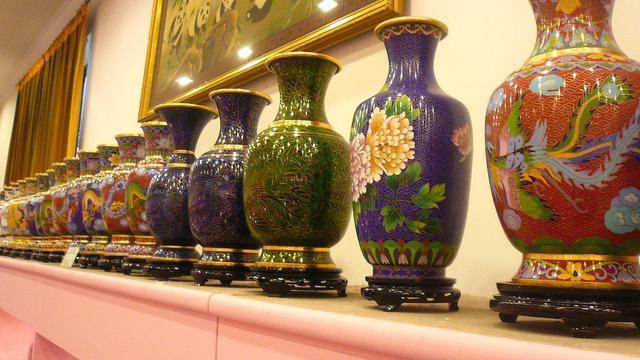How many vases can be seen?
Give a very brief answer. 8. How many people are wearing orange?
Give a very brief answer. 0. 